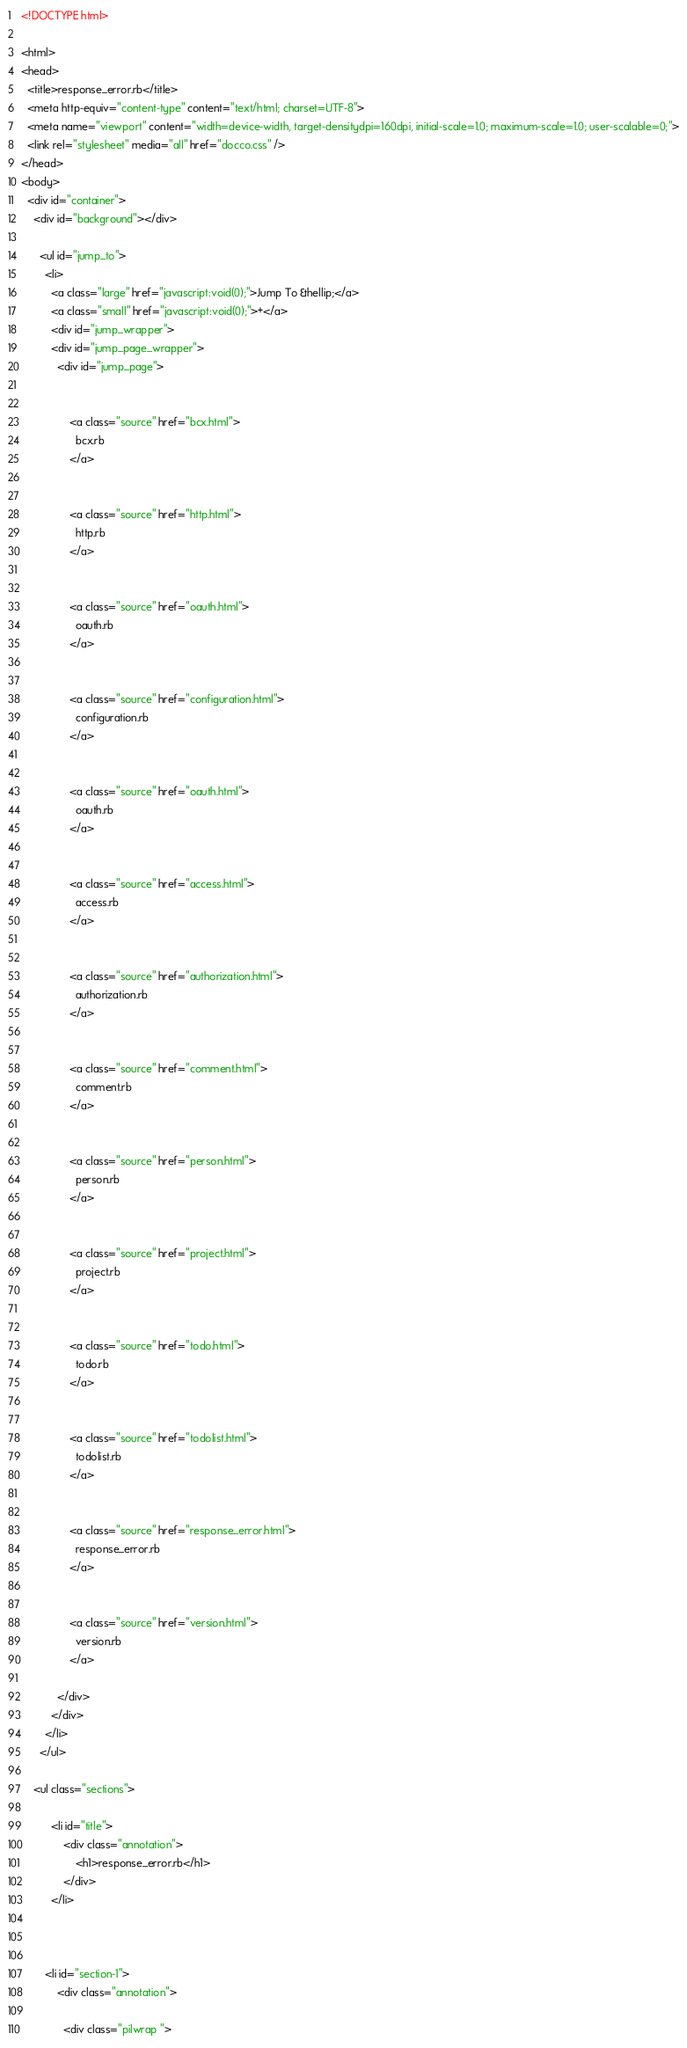Convert code to text. <code><loc_0><loc_0><loc_500><loc_500><_HTML_><!DOCTYPE html>

<html>
<head>
  <title>response_error.rb</title>
  <meta http-equiv="content-type" content="text/html; charset=UTF-8">
  <meta name="viewport" content="width=device-width, target-densitydpi=160dpi, initial-scale=1.0; maximum-scale=1.0; user-scalable=0;">
  <link rel="stylesheet" media="all" href="docco.css" />
</head>
<body>
  <div id="container">
    <div id="background"></div>
    
      <ul id="jump_to">
        <li>
          <a class="large" href="javascript:void(0);">Jump To &hellip;</a>
          <a class="small" href="javascript:void(0);">+</a>
          <div id="jump_wrapper">
          <div id="jump_page_wrapper">
            <div id="jump_page">
              
                
                <a class="source" href="bcx.html">
                  bcx.rb
                </a>
              
                
                <a class="source" href="http.html">
                  http.rb
                </a>
              
                
                <a class="source" href="oauth.html">
                  oauth.rb
                </a>
              
                
                <a class="source" href="configuration.html">
                  configuration.rb
                </a>
              
                
                <a class="source" href="oauth.html">
                  oauth.rb
                </a>
              
                
                <a class="source" href="access.html">
                  access.rb
                </a>
              
                
                <a class="source" href="authorization.html">
                  authorization.rb
                </a>
              
                
                <a class="source" href="comment.html">
                  comment.rb
                </a>
              
                
                <a class="source" href="person.html">
                  person.rb
                </a>
              
                
                <a class="source" href="project.html">
                  project.rb
                </a>
              
                
                <a class="source" href="todo.html">
                  todo.rb
                </a>
              
                
                <a class="source" href="todolist.html">
                  todolist.rb
                </a>
              
                
                <a class="source" href="response_error.html">
                  response_error.rb
                </a>
              
                
                <a class="source" href="version.html">
                  version.rb
                </a>
              
            </div>
          </div>
        </li>
      </ul>
    
    <ul class="sections">
        
          <li id="title">
              <div class="annotation">
                  <h1>response_error.rb</h1>
              </div>
          </li>
        
        
        
        <li id="section-1">
            <div class="annotation">
              
              <div class="pilwrap "></code> 